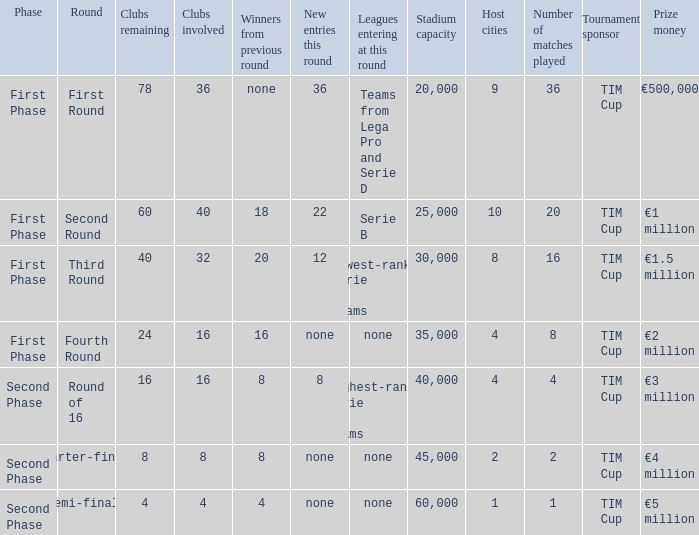From the round name of third round; what would the new entries this round that would be found? 12.0. 